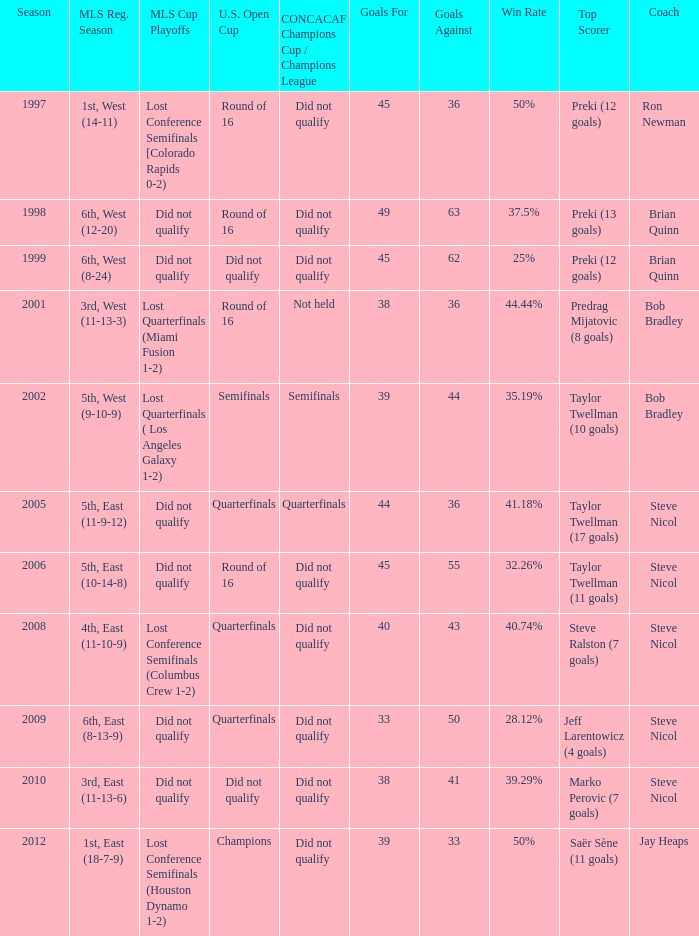When was the first season? 1997.0. 